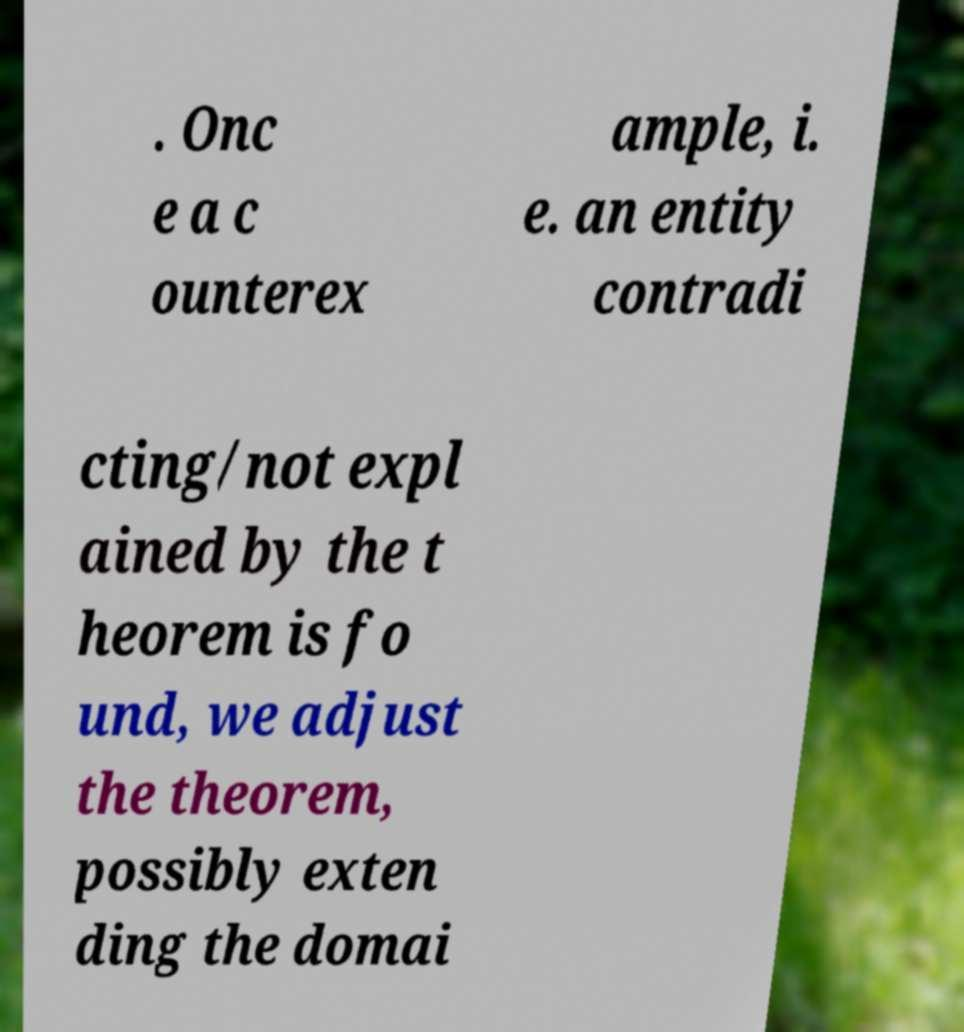Please read and relay the text visible in this image. What does it say? . Onc e a c ounterex ample, i. e. an entity contradi cting/not expl ained by the t heorem is fo und, we adjust the theorem, possibly exten ding the domai 